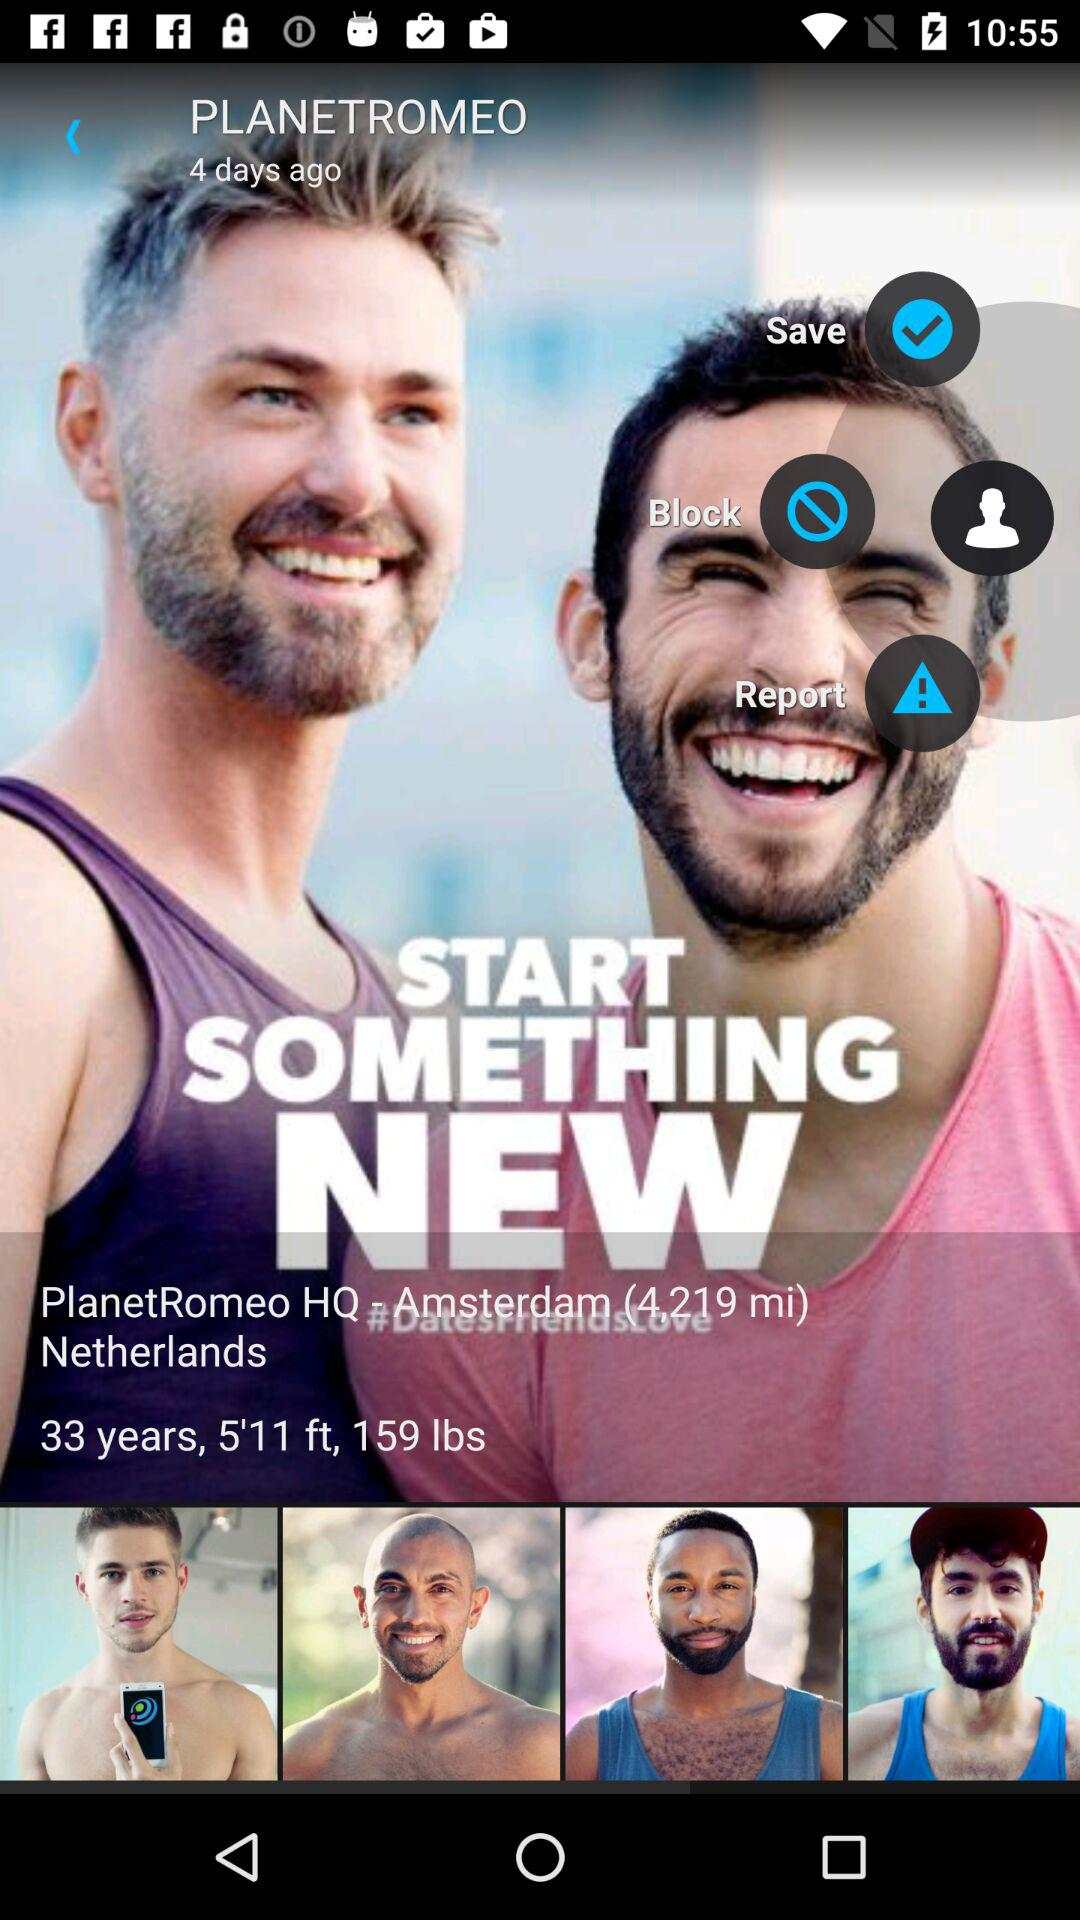Which profiles have been saved?
When the provided information is insufficient, respond with <no answer>. <no answer> 